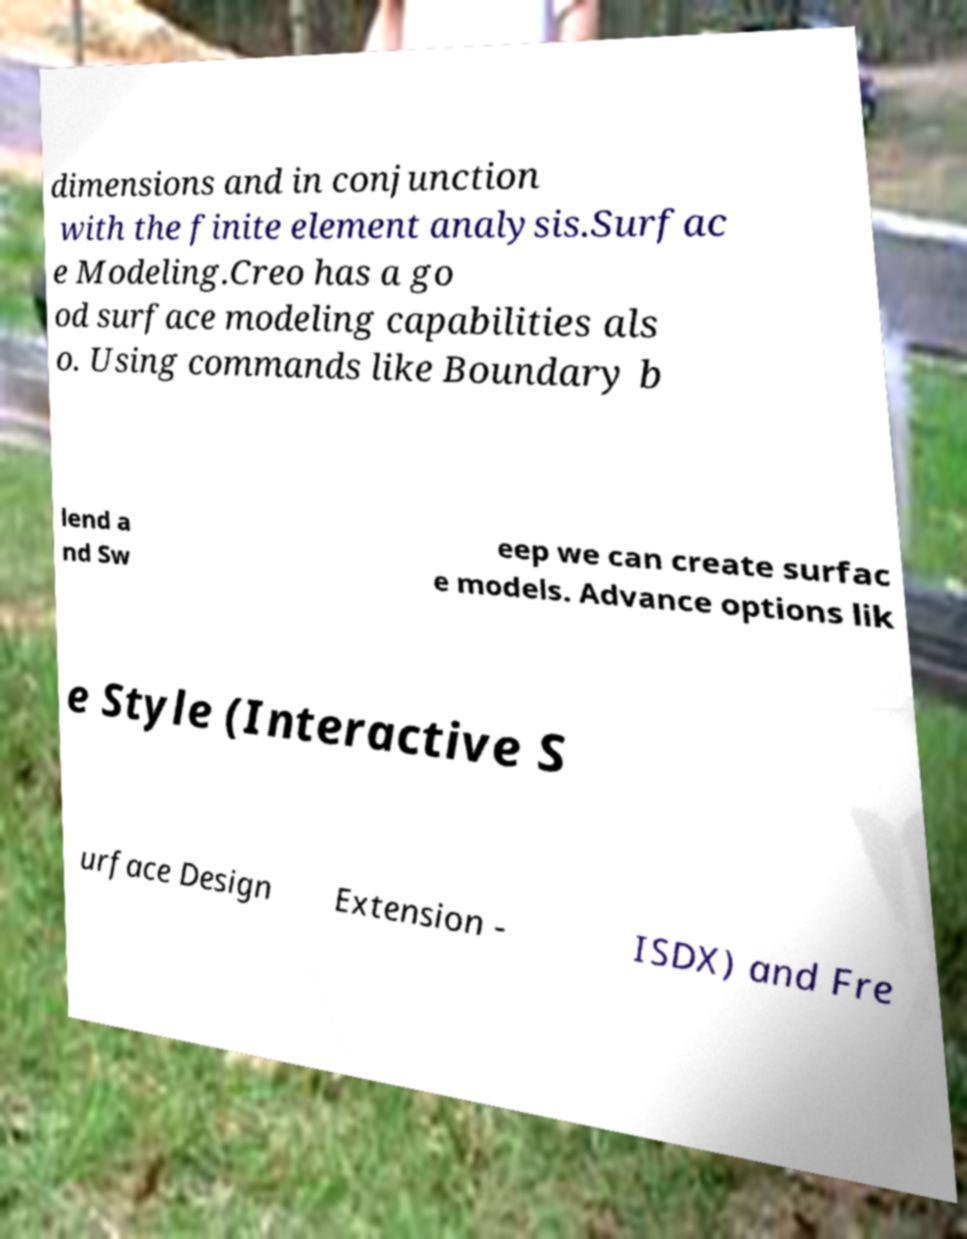Please identify and transcribe the text found in this image. dimensions and in conjunction with the finite element analysis.Surfac e Modeling.Creo has a go od surface modeling capabilities als o. Using commands like Boundary b lend a nd Sw eep we can create surfac e models. Advance options lik e Style (Interactive S urface Design Extension - ISDX) and Fre 